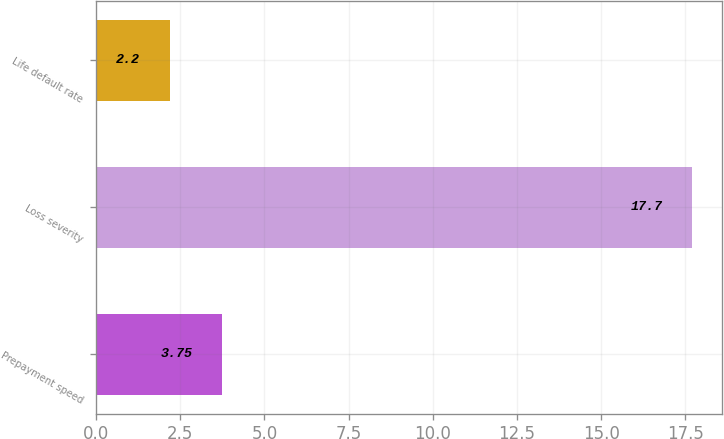<chart> <loc_0><loc_0><loc_500><loc_500><bar_chart><fcel>Prepayment speed<fcel>Loss severity<fcel>Life default rate<nl><fcel>3.75<fcel>17.7<fcel>2.2<nl></chart> 